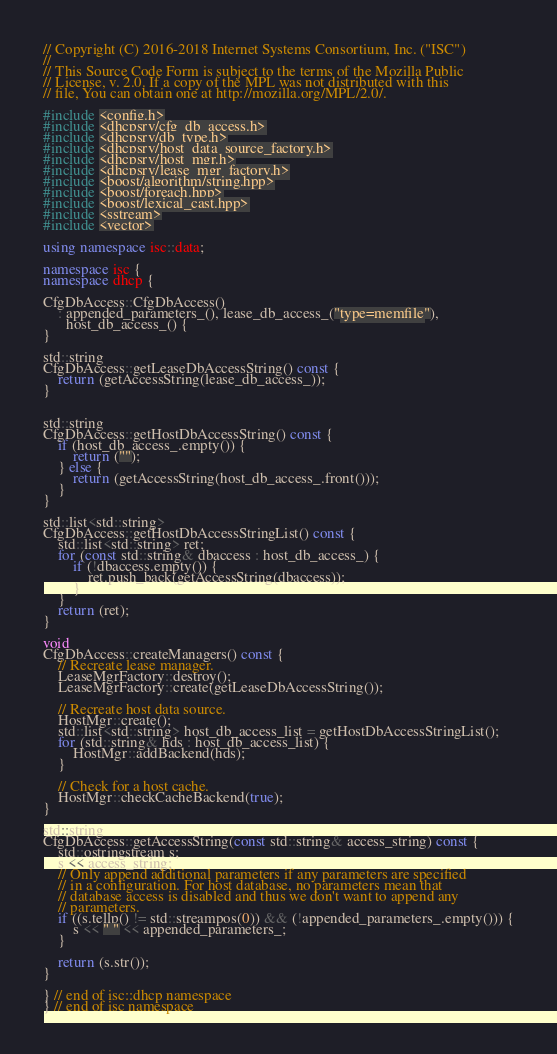<code> <loc_0><loc_0><loc_500><loc_500><_C++_>// Copyright (C) 2016-2018 Internet Systems Consortium, Inc. ("ISC")
//
// This Source Code Form is subject to the terms of the Mozilla Public
// License, v. 2.0. If a copy of the MPL was not distributed with this
// file, You can obtain one at http://mozilla.org/MPL/2.0/.

#include <config.h>
#include <dhcpsrv/cfg_db_access.h>
#include <dhcpsrv/db_type.h>
#include <dhcpsrv/host_data_source_factory.h>
#include <dhcpsrv/host_mgr.h>
#include <dhcpsrv/lease_mgr_factory.h>
#include <boost/algorithm/string.hpp>
#include <boost/foreach.hpp>
#include <boost/lexical_cast.hpp>
#include <sstream>
#include <vector>

using namespace isc::data;

namespace isc {
namespace dhcp {

CfgDbAccess::CfgDbAccess()
    : appended_parameters_(), lease_db_access_("type=memfile"),
      host_db_access_() {
}

std::string
CfgDbAccess::getLeaseDbAccessString() const {
    return (getAccessString(lease_db_access_));
}


std::string
CfgDbAccess::getHostDbAccessString() const {
    if (host_db_access_.empty()) {
        return ("");
    } else {
        return (getAccessString(host_db_access_.front()));
    }
}

std::list<std::string>
CfgDbAccess::getHostDbAccessStringList() const {
    std::list<std::string> ret;
    for (const std::string& dbaccess : host_db_access_) {
        if (!dbaccess.empty()) {
            ret.push_back(getAccessString(dbaccess));
        }
    }
    return (ret);
}

void
CfgDbAccess::createManagers() const {
    // Recreate lease manager.
    LeaseMgrFactory::destroy();
    LeaseMgrFactory::create(getLeaseDbAccessString());

    // Recreate host data source.
    HostMgr::create();
    std::list<std::string> host_db_access_list = getHostDbAccessStringList();
    for (std::string& hds : host_db_access_list) {
        HostMgr::addBackend(hds);
    }

    // Check for a host cache.
    HostMgr::checkCacheBackend(true);
}

std::string
CfgDbAccess::getAccessString(const std::string& access_string) const {
    std::ostringstream s;
    s << access_string;
    // Only append additional parameters if any parameters are specified
    // in a configuration. For host database, no parameters mean that
    // database access is disabled and thus we don't want to append any
    // parameters.
    if ((s.tellp() != std::streampos(0)) && (!appended_parameters_.empty())) {
        s << " " << appended_parameters_;
    }

    return (s.str());
}

} // end of isc::dhcp namespace
} // end of isc namespace
</code> 